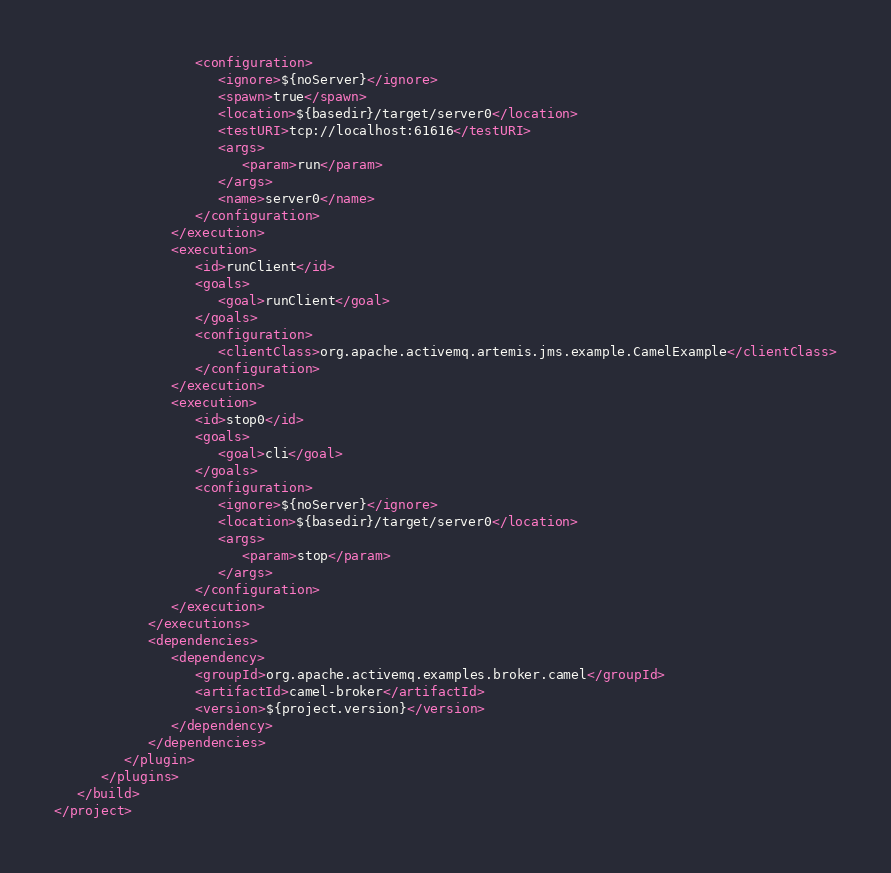<code> <loc_0><loc_0><loc_500><loc_500><_XML_>                  <configuration>
                     <ignore>${noServer}</ignore>
                     <spawn>true</spawn>
                     <location>${basedir}/target/server0</location>
                     <testURI>tcp://localhost:61616</testURI>
                     <args>
                        <param>run</param>
                     </args>
                     <name>server0</name>
                  </configuration>
               </execution>
               <execution>
                  <id>runClient</id>
                  <goals>
                     <goal>runClient</goal>
                  </goals>
                  <configuration>
                     <clientClass>org.apache.activemq.artemis.jms.example.CamelExample</clientClass>
                  </configuration>
               </execution>
               <execution>
                  <id>stop0</id>
                  <goals>
                     <goal>cli</goal>
                  </goals>
                  <configuration>
                     <ignore>${noServer}</ignore>
                     <location>${basedir}/target/server0</location>
                     <args>
                        <param>stop</param>
                     </args>
                  </configuration>
               </execution>
            </executions>
            <dependencies>
               <dependency>
                  <groupId>org.apache.activemq.examples.broker.camel</groupId>
                  <artifactId>camel-broker</artifactId>
                  <version>${project.version}</version>
               </dependency>
            </dependencies>
         </plugin>
      </plugins>
   </build>
</project>
</code> 